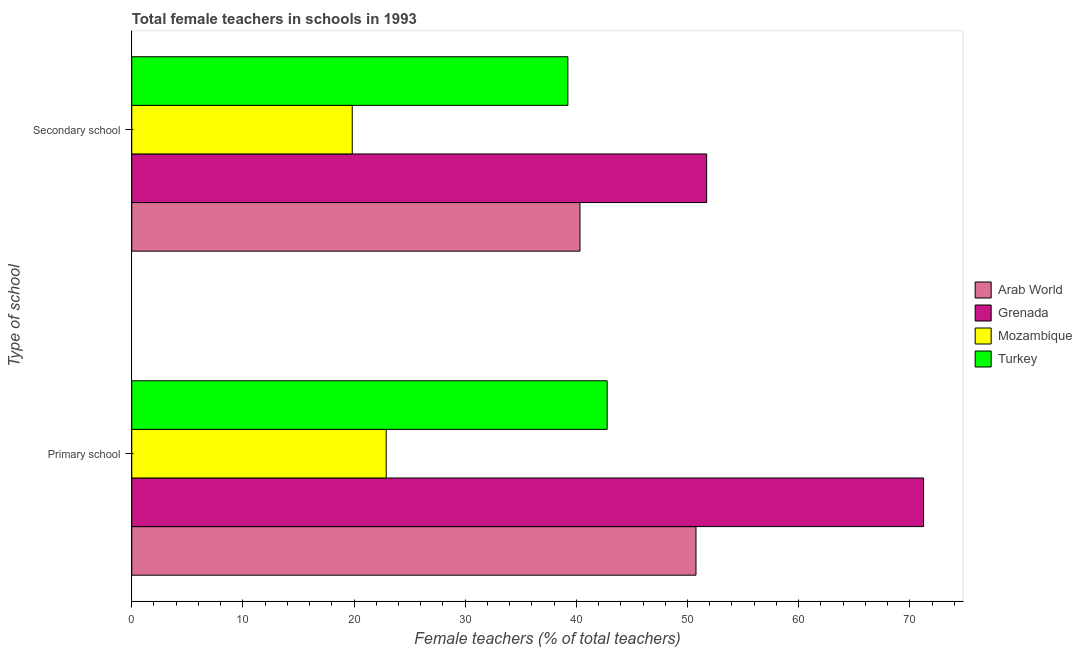How many different coloured bars are there?
Offer a terse response. 4. How many groups of bars are there?
Your answer should be compact. 2. Are the number of bars per tick equal to the number of legend labels?
Ensure brevity in your answer.  Yes. Are the number of bars on each tick of the Y-axis equal?
Keep it short and to the point. Yes. How many bars are there on the 2nd tick from the top?
Your answer should be very brief. 4. How many bars are there on the 1st tick from the bottom?
Your answer should be compact. 4. What is the label of the 1st group of bars from the top?
Make the answer very short. Secondary school. What is the percentage of female teachers in primary schools in Turkey?
Keep it short and to the point. 42.77. Across all countries, what is the maximum percentage of female teachers in primary schools?
Offer a very short reply. 71.24. Across all countries, what is the minimum percentage of female teachers in primary schools?
Ensure brevity in your answer.  22.89. In which country was the percentage of female teachers in secondary schools maximum?
Offer a terse response. Grenada. In which country was the percentage of female teachers in primary schools minimum?
Keep it short and to the point. Mozambique. What is the total percentage of female teachers in secondary schools in the graph?
Ensure brevity in your answer.  151.13. What is the difference between the percentage of female teachers in secondary schools in Grenada and that in Arab World?
Offer a terse response. 11.4. What is the difference between the percentage of female teachers in secondary schools in Grenada and the percentage of female teachers in primary schools in Turkey?
Your response must be concise. 8.95. What is the average percentage of female teachers in primary schools per country?
Provide a short and direct response. 46.92. What is the difference between the percentage of female teachers in primary schools and percentage of female teachers in secondary schools in Grenada?
Keep it short and to the point. 19.52. In how many countries, is the percentage of female teachers in primary schools greater than 10 %?
Keep it short and to the point. 4. What is the ratio of the percentage of female teachers in secondary schools in Mozambique to that in Arab World?
Your answer should be compact. 0.49. Is the percentage of female teachers in primary schools in Arab World less than that in Turkey?
Ensure brevity in your answer.  No. In how many countries, is the percentage of female teachers in secondary schools greater than the average percentage of female teachers in secondary schools taken over all countries?
Offer a terse response. 3. What does the 2nd bar from the top in Secondary school represents?
Make the answer very short. Mozambique. What does the 2nd bar from the bottom in Primary school represents?
Provide a short and direct response. Grenada. Are all the bars in the graph horizontal?
Give a very brief answer. Yes. How many countries are there in the graph?
Your response must be concise. 4. What is the difference between two consecutive major ticks on the X-axis?
Give a very brief answer. 10. Where does the legend appear in the graph?
Give a very brief answer. Center right. How many legend labels are there?
Make the answer very short. 4. How are the legend labels stacked?
Ensure brevity in your answer.  Vertical. What is the title of the graph?
Keep it short and to the point. Total female teachers in schools in 1993. Does "Ethiopia" appear as one of the legend labels in the graph?
Provide a succinct answer. No. What is the label or title of the X-axis?
Keep it short and to the point. Female teachers (% of total teachers). What is the label or title of the Y-axis?
Keep it short and to the point. Type of school. What is the Female teachers (% of total teachers) in Arab World in Primary school?
Keep it short and to the point. 50.76. What is the Female teachers (% of total teachers) of Grenada in Primary school?
Provide a short and direct response. 71.24. What is the Female teachers (% of total teachers) of Mozambique in Primary school?
Provide a succinct answer. 22.89. What is the Female teachers (% of total teachers) in Turkey in Primary school?
Your response must be concise. 42.77. What is the Female teachers (% of total teachers) in Arab World in Secondary school?
Make the answer very short. 40.33. What is the Female teachers (% of total teachers) in Grenada in Secondary school?
Keep it short and to the point. 51.72. What is the Female teachers (% of total teachers) in Mozambique in Secondary school?
Keep it short and to the point. 19.84. What is the Female teachers (% of total teachers) of Turkey in Secondary school?
Offer a terse response. 39.24. Across all Type of school, what is the maximum Female teachers (% of total teachers) of Arab World?
Offer a terse response. 50.76. Across all Type of school, what is the maximum Female teachers (% of total teachers) in Grenada?
Your answer should be very brief. 71.24. Across all Type of school, what is the maximum Female teachers (% of total teachers) in Mozambique?
Ensure brevity in your answer.  22.89. Across all Type of school, what is the maximum Female teachers (% of total teachers) of Turkey?
Offer a very short reply. 42.77. Across all Type of school, what is the minimum Female teachers (% of total teachers) in Arab World?
Your answer should be very brief. 40.33. Across all Type of school, what is the minimum Female teachers (% of total teachers) of Grenada?
Offer a terse response. 51.72. Across all Type of school, what is the minimum Female teachers (% of total teachers) in Mozambique?
Your answer should be very brief. 19.84. Across all Type of school, what is the minimum Female teachers (% of total teachers) in Turkey?
Your answer should be very brief. 39.24. What is the total Female teachers (% of total teachers) of Arab World in the graph?
Your answer should be compact. 91.09. What is the total Female teachers (% of total teachers) of Grenada in the graph?
Your response must be concise. 122.96. What is the total Female teachers (% of total teachers) of Mozambique in the graph?
Your response must be concise. 42.73. What is the total Female teachers (% of total teachers) of Turkey in the graph?
Ensure brevity in your answer.  82.01. What is the difference between the Female teachers (% of total teachers) in Arab World in Primary school and that in Secondary school?
Ensure brevity in your answer.  10.44. What is the difference between the Female teachers (% of total teachers) in Grenada in Primary school and that in Secondary school?
Make the answer very short. 19.52. What is the difference between the Female teachers (% of total teachers) of Mozambique in Primary school and that in Secondary school?
Offer a very short reply. 3.05. What is the difference between the Female teachers (% of total teachers) in Turkey in Primary school and that in Secondary school?
Ensure brevity in your answer.  3.54. What is the difference between the Female teachers (% of total teachers) of Arab World in Primary school and the Female teachers (% of total teachers) of Grenada in Secondary school?
Offer a terse response. -0.96. What is the difference between the Female teachers (% of total teachers) in Arab World in Primary school and the Female teachers (% of total teachers) in Mozambique in Secondary school?
Make the answer very short. 30.93. What is the difference between the Female teachers (% of total teachers) in Arab World in Primary school and the Female teachers (% of total teachers) in Turkey in Secondary school?
Your answer should be very brief. 11.53. What is the difference between the Female teachers (% of total teachers) in Grenada in Primary school and the Female teachers (% of total teachers) in Mozambique in Secondary school?
Ensure brevity in your answer.  51.4. What is the difference between the Female teachers (% of total teachers) of Grenada in Primary school and the Female teachers (% of total teachers) of Turkey in Secondary school?
Offer a terse response. 32. What is the difference between the Female teachers (% of total teachers) of Mozambique in Primary school and the Female teachers (% of total teachers) of Turkey in Secondary school?
Offer a very short reply. -16.34. What is the average Female teachers (% of total teachers) in Arab World per Type of school?
Ensure brevity in your answer.  45.55. What is the average Female teachers (% of total teachers) of Grenada per Type of school?
Make the answer very short. 61.48. What is the average Female teachers (% of total teachers) of Mozambique per Type of school?
Keep it short and to the point. 21.37. What is the average Female teachers (% of total teachers) in Turkey per Type of school?
Give a very brief answer. 41. What is the difference between the Female teachers (% of total teachers) in Arab World and Female teachers (% of total teachers) in Grenada in Primary school?
Keep it short and to the point. -20.47. What is the difference between the Female teachers (% of total teachers) in Arab World and Female teachers (% of total teachers) in Mozambique in Primary school?
Provide a succinct answer. 27.87. What is the difference between the Female teachers (% of total teachers) of Arab World and Female teachers (% of total teachers) of Turkey in Primary school?
Ensure brevity in your answer.  7.99. What is the difference between the Female teachers (% of total teachers) in Grenada and Female teachers (% of total teachers) in Mozambique in Primary school?
Offer a terse response. 48.35. What is the difference between the Female teachers (% of total teachers) in Grenada and Female teachers (% of total teachers) in Turkey in Primary school?
Make the answer very short. 28.47. What is the difference between the Female teachers (% of total teachers) in Mozambique and Female teachers (% of total teachers) in Turkey in Primary school?
Ensure brevity in your answer.  -19.88. What is the difference between the Female teachers (% of total teachers) of Arab World and Female teachers (% of total teachers) of Grenada in Secondary school?
Give a very brief answer. -11.4. What is the difference between the Female teachers (% of total teachers) in Arab World and Female teachers (% of total teachers) in Mozambique in Secondary school?
Offer a terse response. 20.49. What is the difference between the Female teachers (% of total teachers) of Arab World and Female teachers (% of total teachers) of Turkey in Secondary school?
Give a very brief answer. 1.09. What is the difference between the Female teachers (% of total teachers) in Grenada and Female teachers (% of total teachers) in Mozambique in Secondary school?
Give a very brief answer. 31.89. What is the difference between the Female teachers (% of total teachers) of Grenada and Female teachers (% of total teachers) of Turkey in Secondary school?
Ensure brevity in your answer.  12.49. What is the difference between the Female teachers (% of total teachers) in Mozambique and Female teachers (% of total teachers) in Turkey in Secondary school?
Your answer should be compact. -19.4. What is the ratio of the Female teachers (% of total teachers) in Arab World in Primary school to that in Secondary school?
Offer a very short reply. 1.26. What is the ratio of the Female teachers (% of total teachers) of Grenada in Primary school to that in Secondary school?
Make the answer very short. 1.38. What is the ratio of the Female teachers (% of total teachers) of Mozambique in Primary school to that in Secondary school?
Your answer should be very brief. 1.15. What is the ratio of the Female teachers (% of total teachers) in Turkey in Primary school to that in Secondary school?
Offer a terse response. 1.09. What is the difference between the highest and the second highest Female teachers (% of total teachers) of Arab World?
Keep it short and to the point. 10.44. What is the difference between the highest and the second highest Female teachers (% of total teachers) of Grenada?
Give a very brief answer. 19.52. What is the difference between the highest and the second highest Female teachers (% of total teachers) of Mozambique?
Your response must be concise. 3.05. What is the difference between the highest and the second highest Female teachers (% of total teachers) in Turkey?
Give a very brief answer. 3.54. What is the difference between the highest and the lowest Female teachers (% of total teachers) of Arab World?
Make the answer very short. 10.44. What is the difference between the highest and the lowest Female teachers (% of total teachers) of Grenada?
Your response must be concise. 19.52. What is the difference between the highest and the lowest Female teachers (% of total teachers) in Mozambique?
Offer a very short reply. 3.05. What is the difference between the highest and the lowest Female teachers (% of total teachers) in Turkey?
Provide a succinct answer. 3.54. 